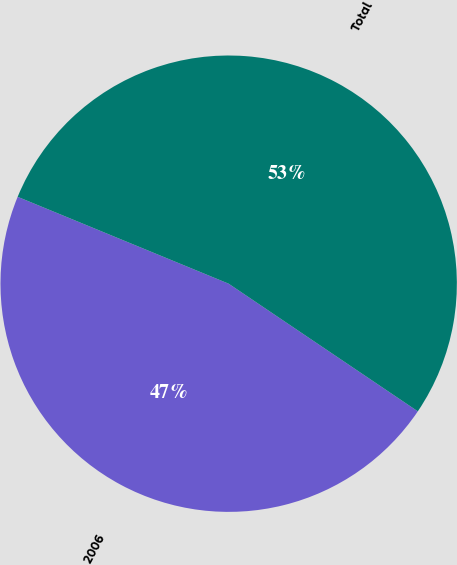Convert chart to OTSL. <chart><loc_0><loc_0><loc_500><loc_500><pie_chart><fcel>2006<fcel>Total<nl><fcel>46.77%<fcel>53.23%<nl></chart> 